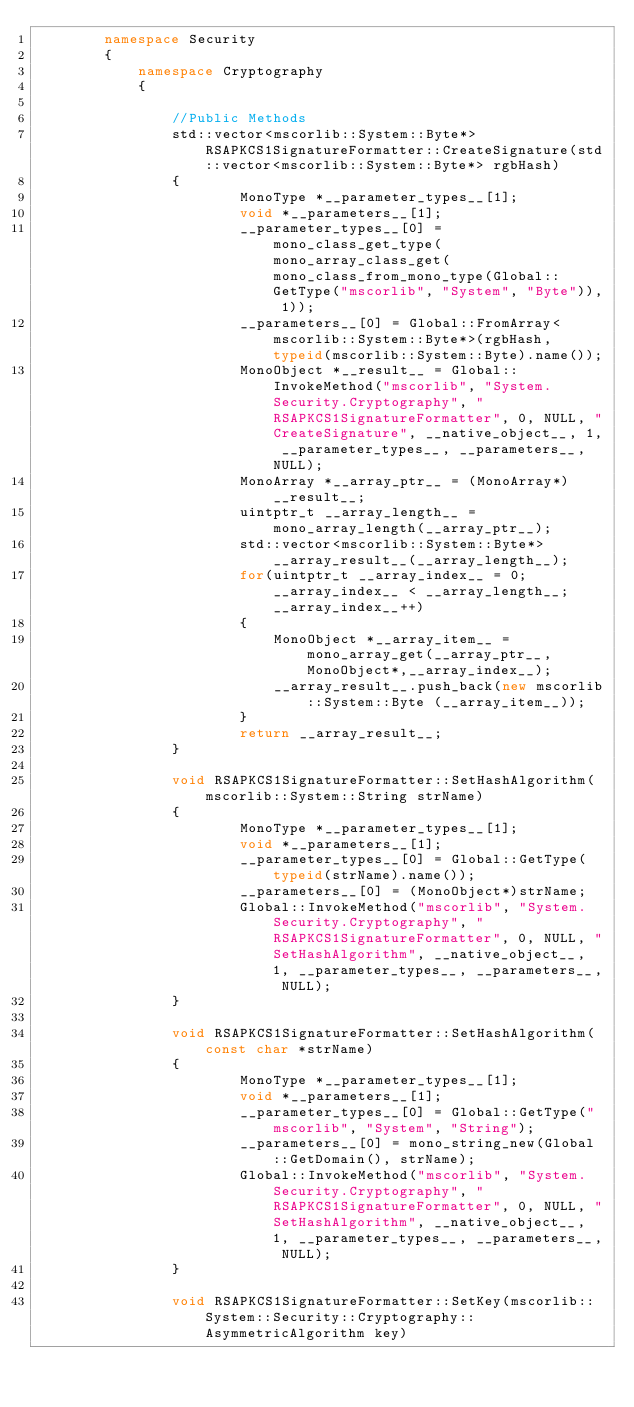Convert code to text. <code><loc_0><loc_0><loc_500><loc_500><_C++_>		namespace Security
		{
			namespace Cryptography
			{

				//Public Methods
				std::vector<mscorlib::System::Byte*> RSAPKCS1SignatureFormatter::CreateSignature(std::vector<mscorlib::System::Byte*> rgbHash)
				{
						MonoType *__parameter_types__[1];
						void *__parameters__[1];
						__parameter_types__[0] = mono_class_get_type(mono_array_class_get(mono_class_from_mono_type(Global::GetType("mscorlib", "System", "Byte")), 1));
						__parameters__[0] = Global::FromArray<mscorlib::System::Byte*>(rgbHash, typeid(mscorlib::System::Byte).name());
						MonoObject *__result__ = Global::InvokeMethod("mscorlib", "System.Security.Cryptography", "RSAPKCS1SignatureFormatter", 0, NULL, "CreateSignature", __native_object__, 1, __parameter_types__, __parameters__, NULL);
						MonoArray *__array_ptr__ = (MonoArray*)__result__;
						uintptr_t __array_length__ = mono_array_length(__array_ptr__);
						std::vector<mscorlib::System::Byte*>  __array_result__(__array_length__);
						for(uintptr_t __array_index__ = 0; __array_index__ < __array_length__; __array_index__++)
						{
							MonoObject *__array_item__ = mono_array_get(__array_ptr__,MonoObject*,__array_index__);
							__array_result__.push_back(new mscorlib::System::Byte (__array_item__));
						}
						return __array_result__;
				}

				void RSAPKCS1SignatureFormatter::SetHashAlgorithm(mscorlib::System::String strName)
				{
						MonoType *__parameter_types__[1];
						void *__parameters__[1];
						__parameter_types__[0] = Global::GetType(typeid(strName).name());
						__parameters__[0] = (MonoObject*)strName;
						Global::InvokeMethod("mscorlib", "System.Security.Cryptography", "RSAPKCS1SignatureFormatter", 0, NULL, "SetHashAlgorithm", __native_object__, 1, __parameter_types__, __parameters__, NULL);
				}

				void RSAPKCS1SignatureFormatter::SetHashAlgorithm(const char *strName)
				{
						MonoType *__parameter_types__[1];
						void *__parameters__[1];
						__parameter_types__[0] = Global::GetType("mscorlib", "System", "String");
						__parameters__[0] = mono_string_new(Global::GetDomain(), strName);
						Global::InvokeMethod("mscorlib", "System.Security.Cryptography", "RSAPKCS1SignatureFormatter", 0, NULL, "SetHashAlgorithm", __native_object__, 1, __parameter_types__, __parameters__, NULL);
				}

				void RSAPKCS1SignatureFormatter::SetKey(mscorlib::System::Security::Cryptography::AsymmetricAlgorithm key)</code> 